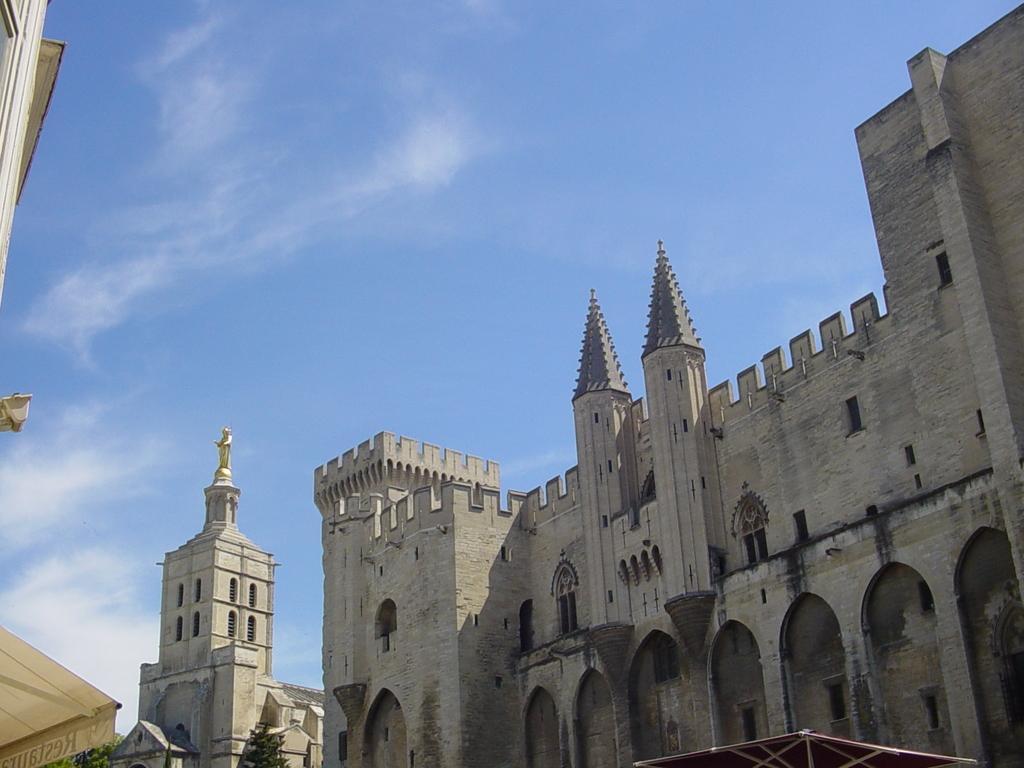Could you give a brief overview of what you see in this image? In this image we can see buildings, trees, statue and sky with clouds. 